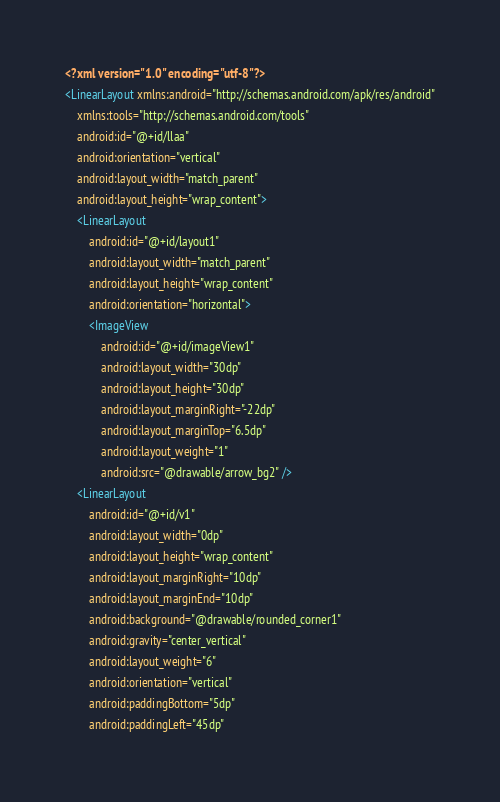<code> <loc_0><loc_0><loc_500><loc_500><_XML_><?xml version="1.0" encoding="utf-8"?>
<LinearLayout xmlns:android="http://schemas.android.com/apk/res/android"
    xmlns:tools="http://schemas.android.com/tools"
    android:id="@+id/llaa"
    android:orientation="vertical"
    android:layout_width="match_parent"
    android:layout_height="wrap_content">
    <LinearLayout
        android:id="@+id/layout1"
        android:layout_width="match_parent"
        android:layout_height="wrap_content"
        android:orientation="horizontal">
        <ImageView
            android:id="@+id/imageView1"
            android:layout_width="30dp"
            android:layout_height="30dp"
            android:layout_marginRight="-22dp"
            android:layout_marginTop="6.5dp"
            android:layout_weight="1"
            android:src="@drawable/arrow_bg2" />
    <LinearLayout
        android:id="@+id/v1"
        android:layout_width="0dp"
        android:layout_height="wrap_content"
        android:layout_marginRight="10dp"
        android:layout_marginEnd="10dp"
        android:background="@drawable/rounded_corner1"
        android:gravity="center_vertical"
        android:layout_weight="6"
        android:orientation="vertical"
        android:paddingBottom="5dp"
        android:paddingLeft="45dp"</code> 